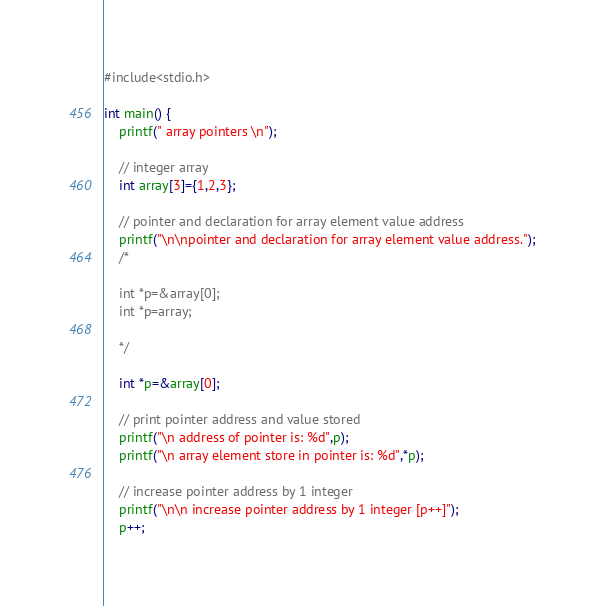<code> <loc_0><loc_0><loc_500><loc_500><_C_>#include<stdio.h>

int main() {
    printf(" array pointers \n");
    
    // integer array
    int array[3]={1,2,3};

    // pointer and declaration for array element value address
    printf("\n\npointer and declaration for array element value address.");
    /*
    
    int *p=&array[0];
    int *p=array;

    */

    int *p=&array[0];

    // print pointer address and value stored
    printf("\n address of pointer is: %d",p);
    printf("\n array element store in pointer is: %d",*p);

    // increase pointer address by 1 integer
    printf("\n\n increase pointer address by 1 integer [p++]");
    p++;</code> 